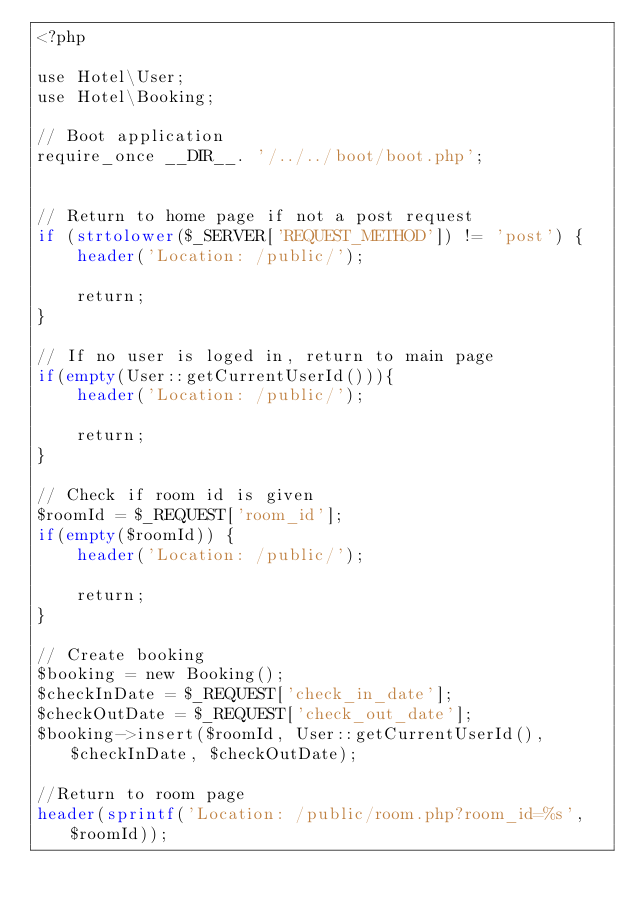<code> <loc_0><loc_0><loc_500><loc_500><_PHP_><?php

use Hotel\User;
use Hotel\Booking;

// Boot application
require_once __DIR__. '/../../boot/boot.php';


// Return to home page if not a post request
if (strtolower($_SERVER['REQUEST_METHOD']) != 'post') {
	header('Location: /public/');
	
	return;
}

// If no user is loged in, return to main page
if(empty(User::getCurrentUserId())){
	header('Location: /public/');
	
	return;
}

// Check if room id is given
$roomId = $_REQUEST['room_id'];
if(empty($roomId)) {
	header('Location: /public/');
	
	return;
}

// Create booking
$booking = new Booking();
$checkInDate = $_REQUEST['check_in_date'];
$checkOutDate = $_REQUEST['check_out_date'];
$booking->insert($roomId, User::getCurrentUserId(), $checkInDate, $checkOutDate);

//Return to room page
header(sprintf('Location: /public/room.php?room_id=%s',$roomId));
</code> 